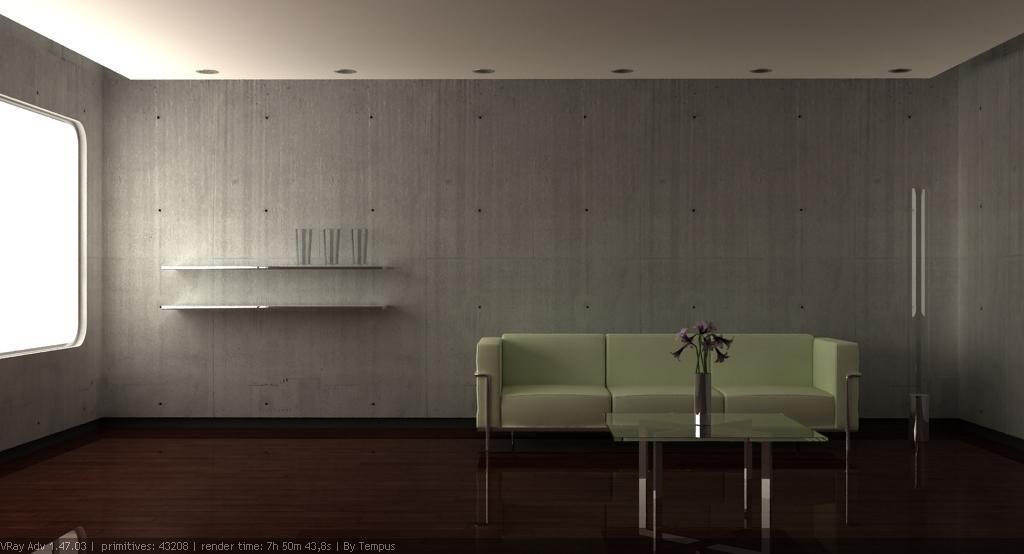Please provide a concise description of this image. In this picture as a sofa is also glass table and plant kept on it left there side is a window 